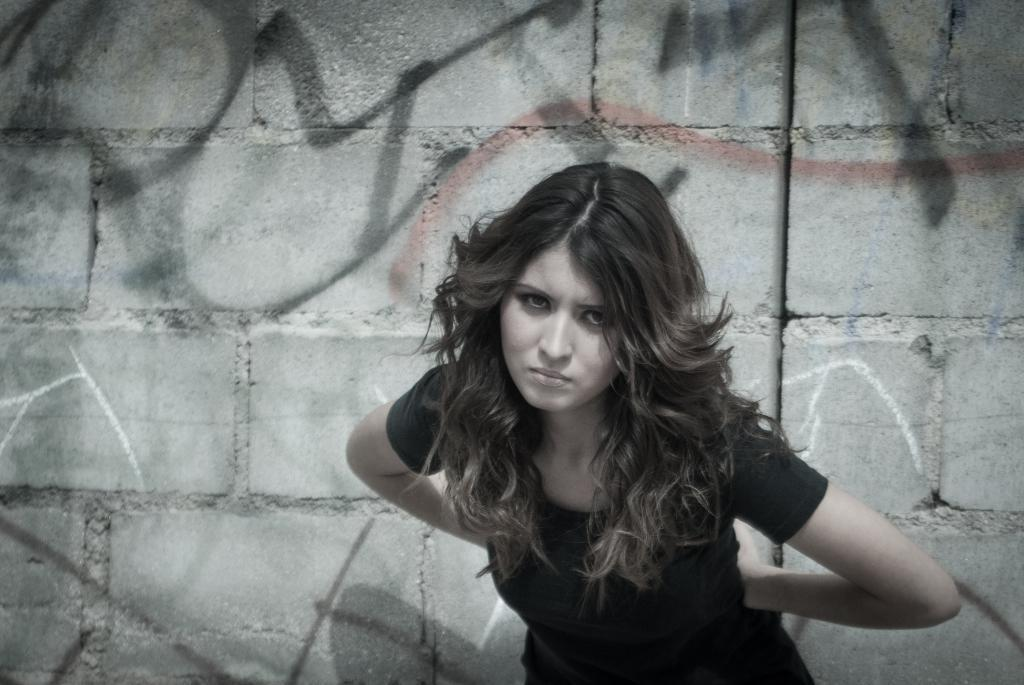Who is present in the image? There is a woman in the image. What is the woman wearing? The woman is wearing a black t-shirt. What can be seen in the background of the image? There is a wall in the background of the image. What type of farming equipment can be seen in the image? There is no farming equipment present in the image; it features a woman wearing a black t-shirt with a wall in the background. 